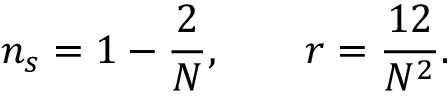Convert formula to latex. <formula><loc_0><loc_0><loc_500><loc_500>n _ { s } = 1 - { \frac { 2 } { N } } , \quad r = { \frac { 1 2 } { N ^ { 2 } } } .</formula> 